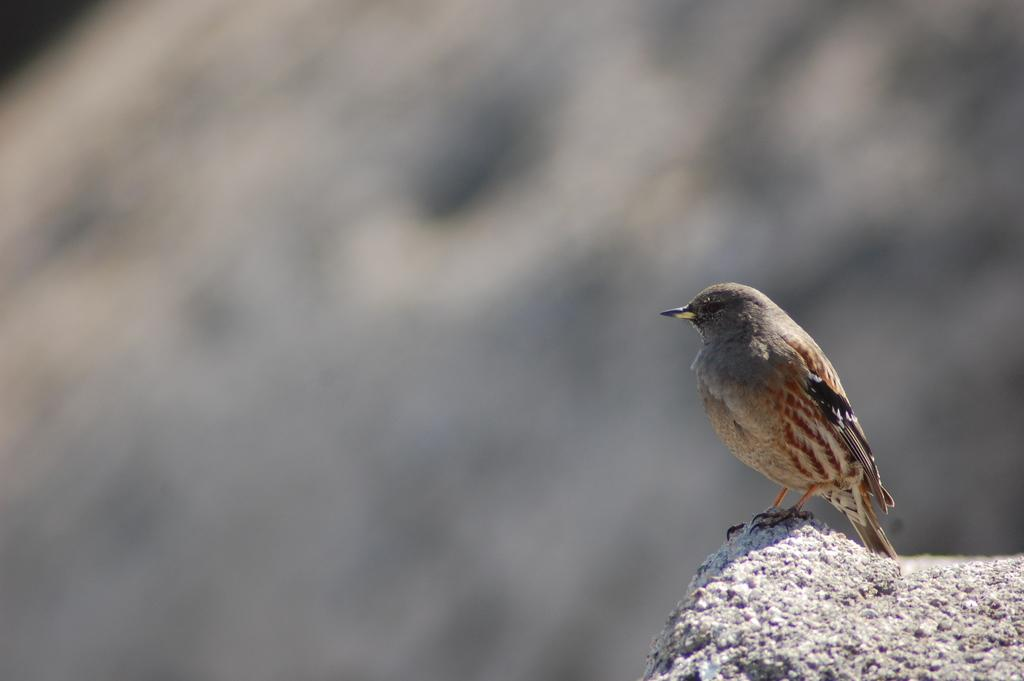What type of animal is present in the image? There is a bird in the image. Where is the bird located? The bird is on a rock surface. Can you describe the background of the image? The background of the image is blurry. What type of linen is being used by the bird in the image? There is no linen present in the image; it features a bird on a rock surface with a blurry background. 